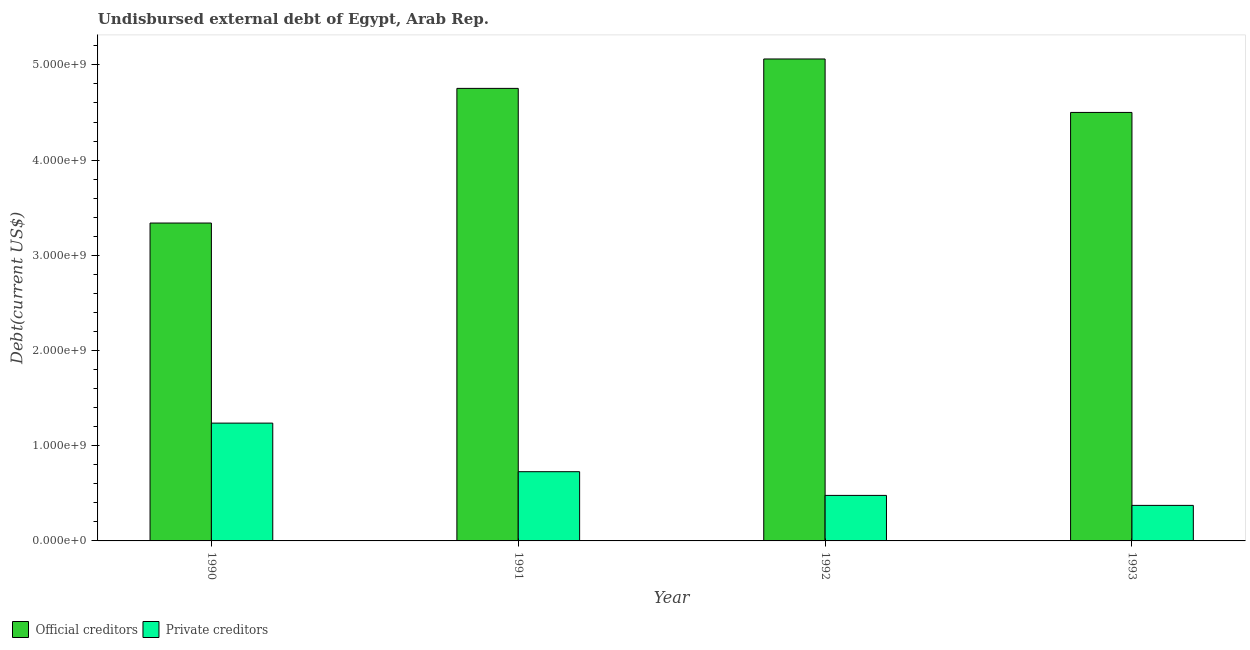How many different coloured bars are there?
Your answer should be very brief. 2. How many groups of bars are there?
Ensure brevity in your answer.  4. How many bars are there on the 2nd tick from the right?
Keep it short and to the point. 2. What is the label of the 2nd group of bars from the left?
Give a very brief answer. 1991. What is the undisbursed external debt of private creditors in 1993?
Your answer should be very brief. 3.73e+08. Across all years, what is the maximum undisbursed external debt of private creditors?
Keep it short and to the point. 1.24e+09. Across all years, what is the minimum undisbursed external debt of official creditors?
Your answer should be very brief. 3.34e+09. In which year was the undisbursed external debt of private creditors maximum?
Provide a succinct answer. 1990. What is the total undisbursed external debt of official creditors in the graph?
Keep it short and to the point. 1.77e+1. What is the difference between the undisbursed external debt of private creditors in 1992 and that in 1993?
Provide a short and direct response. 1.05e+08. What is the difference between the undisbursed external debt of private creditors in 1990 and the undisbursed external debt of official creditors in 1991?
Your response must be concise. 5.10e+08. What is the average undisbursed external debt of private creditors per year?
Offer a terse response. 7.04e+08. What is the ratio of the undisbursed external debt of private creditors in 1990 to that in 1992?
Your response must be concise. 2.59. Is the difference between the undisbursed external debt of official creditors in 1990 and 1991 greater than the difference between the undisbursed external debt of private creditors in 1990 and 1991?
Offer a terse response. No. What is the difference between the highest and the second highest undisbursed external debt of private creditors?
Your answer should be compact. 5.10e+08. What is the difference between the highest and the lowest undisbursed external debt of private creditors?
Make the answer very short. 8.64e+08. Is the sum of the undisbursed external debt of private creditors in 1991 and 1993 greater than the maximum undisbursed external debt of official creditors across all years?
Ensure brevity in your answer.  No. What does the 1st bar from the left in 1993 represents?
Offer a terse response. Official creditors. What does the 2nd bar from the right in 1993 represents?
Keep it short and to the point. Official creditors. What is the difference between two consecutive major ticks on the Y-axis?
Keep it short and to the point. 1.00e+09. How are the legend labels stacked?
Provide a short and direct response. Horizontal. What is the title of the graph?
Your answer should be very brief. Undisbursed external debt of Egypt, Arab Rep. What is the label or title of the Y-axis?
Ensure brevity in your answer.  Debt(current US$). What is the Debt(current US$) in Official creditors in 1990?
Keep it short and to the point. 3.34e+09. What is the Debt(current US$) in Private creditors in 1990?
Your answer should be very brief. 1.24e+09. What is the Debt(current US$) in Official creditors in 1991?
Provide a short and direct response. 4.75e+09. What is the Debt(current US$) in Private creditors in 1991?
Make the answer very short. 7.27e+08. What is the Debt(current US$) in Official creditors in 1992?
Ensure brevity in your answer.  5.06e+09. What is the Debt(current US$) in Private creditors in 1992?
Offer a very short reply. 4.78e+08. What is the Debt(current US$) of Official creditors in 1993?
Offer a very short reply. 4.50e+09. What is the Debt(current US$) of Private creditors in 1993?
Give a very brief answer. 3.73e+08. Across all years, what is the maximum Debt(current US$) of Official creditors?
Make the answer very short. 5.06e+09. Across all years, what is the maximum Debt(current US$) of Private creditors?
Your response must be concise. 1.24e+09. Across all years, what is the minimum Debt(current US$) in Official creditors?
Make the answer very short. 3.34e+09. Across all years, what is the minimum Debt(current US$) in Private creditors?
Keep it short and to the point. 3.73e+08. What is the total Debt(current US$) in Official creditors in the graph?
Make the answer very short. 1.77e+1. What is the total Debt(current US$) in Private creditors in the graph?
Provide a succinct answer. 2.82e+09. What is the difference between the Debt(current US$) of Official creditors in 1990 and that in 1991?
Provide a short and direct response. -1.41e+09. What is the difference between the Debt(current US$) of Private creditors in 1990 and that in 1991?
Your answer should be compact. 5.10e+08. What is the difference between the Debt(current US$) in Official creditors in 1990 and that in 1992?
Give a very brief answer. -1.72e+09. What is the difference between the Debt(current US$) in Private creditors in 1990 and that in 1992?
Ensure brevity in your answer.  7.59e+08. What is the difference between the Debt(current US$) in Official creditors in 1990 and that in 1993?
Give a very brief answer. -1.16e+09. What is the difference between the Debt(current US$) in Private creditors in 1990 and that in 1993?
Your answer should be very brief. 8.64e+08. What is the difference between the Debt(current US$) in Official creditors in 1991 and that in 1992?
Offer a very short reply. -3.09e+08. What is the difference between the Debt(current US$) of Private creditors in 1991 and that in 1992?
Your answer should be very brief. 2.49e+08. What is the difference between the Debt(current US$) of Official creditors in 1991 and that in 1993?
Keep it short and to the point. 2.53e+08. What is the difference between the Debt(current US$) in Private creditors in 1991 and that in 1993?
Offer a terse response. 3.54e+08. What is the difference between the Debt(current US$) in Official creditors in 1992 and that in 1993?
Your answer should be very brief. 5.61e+08. What is the difference between the Debt(current US$) of Private creditors in 1992 and that in 1993?
Offer a very short reply. 1.05e+08. What is the difference between the Debt(current US$) in Official creditors in 1990 and the Debt(current US$) in Private creditors in 1991?
Offer a very short reply. 2.61e+09. What is the difference between the Debt(current US$) in Official creditors in 1990 and the Debt(current US$) in Private creditors in 1992?
Your answer should be compact. 2.86e+09. What is the difference between the Debt(current US$) in Official creditors in 1990 and the Debt(current US$) in Private creditors in 1993?
Your answer should be very brief. 2.97e+09. What is the difference between the Debt(current US$) in Official creditors in 1991 and the Debt(current US$) in Private creditors in 1992?
Offer a terse response. 4.28e+09. What is the difference between the Debt(current US$) in Official creditors in 1991 and the Debt(current US$) in Private creditors in 1993?
Ensure brevity in your answer.  4.38e+09. What is the difference between the Debt(current US$) of Official creditors in 1992 and the Debt(current US$) of Private creditors in 1993?
Your answer should be very brief. 4.69e+09. What is the average Debt(current US$) in Official creditors per year?
Provide a short and direct response. 4.41e+09. What is the average Debt(current US$) in Private creditors per year?
Give a very brief answer. 7.04e+08. In the year 1990, what is the difference between the Debt(current US$) in Official creditors and Debt(current US$) in Private creditors?
Make the answer very short. 2.10e+09. In the year 1991, what is the difference between the Debt(current US$) in Official creditors and Debt(current US$) in Private creditors?
Give a very brief answer. 4.03e+09. In the year 1992, what is the difference between the Debt(current US$) of Official creditors and Debt(current US$) of Private creditors?
Your answer should be compact. 4.58e+09. In the year 1993, what is the difference between the Debt(current US$) in Official creditors and Debt(current US$) in Private creditors?
Your response must be concise. 4.13e+09. What is the ratio of the Debt(current US$) in Official creditors in 1990 to that in 1991?
Make the answer very short. 0.7. What is the ratio of the Debt(current US$) of Private creditors in 1990 to that in 1991?
Keep it short and to the point. 1.7. What is the ratio of the Debt(current US$) of Official creditors in 1990 to that in 1992?
Keep it short and to the point. 0.66. What is the ratio of the Debt(current US$) of Private creditors in 1990 to that in 1992?
Offer a terse response. 2.59. What is the ratio of the Debt(current US$) of Official creditors in 1990 to that in 1993?
Provide a short and direct response. 0.74. What is the ratio of the Debt(current US$) of Private creditors in 1990 to that in 1993?
Make the answer very short. 3.31. What is the ratio of the Debt(current US$) of Official creditors in 1991 to that in 1992?
Your response must be concise. 0.94. What is the ratio of the Debt(current US$) in Private creditors in 1991 to that in 1992?
Offer a very short reply. 1.52. What is the ratio of the Debt(current US$) in Official creditors in 1991 to that in 1993?
Your answer should be very brief. 1.06. What is the ratio of the Debt(current US$) of Private creditors in 1991 to that in 1993?
Ensure brevity in your answer.  1.95. What is the ratio of the Debt(current US$) in Official creditors in 1992 to that in 1993?
Your answer should be compact. 1.12. What is the ratio of the Debt(current US$) of Private creditors in 1992 to that in 1993?
Your answer should be very brief. 1.28. What is the difference between the highest and the second highest Debt(current US$) of Official creditors?
Provide a short and direct response. 3.09e+08. What is the difference between the highest and the second highest Debt(current US$) in Private creditors?
Provide a short and direct response. 5.10e+08. What is the difference between the highest and the lowest Debt(current US$) in Official creditors?
Give a very brief answer. 1.72e+09. What is the difference between the highest and the lowest Debt(current US$) of Private creditors?
Offer a very short reply. 8.64e+08. 